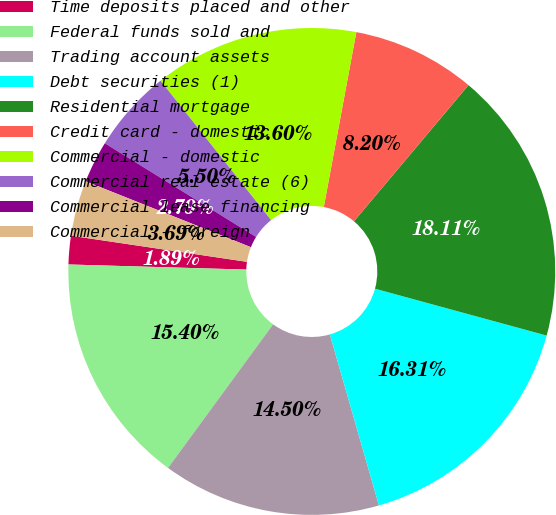Convert chart. <chart><loc_0><loc_0><loc_500><loc_500><pie_chart><fcel>Time deposits placed and other<fcel>Federal funds sold and<fcel>Trading account assets<fcel>Debt securities (1)<fcel>Residential mortgage<fcel>Credit card - domestic<fcel>Commercial - domestic<fcel>Commercial real estate (6)<fcel>Commercial lease financing<fcel>Commercial - foreign<nl><fcel>1.89%<fcel>15.4%<fcel>14.5%<fcel>16.31%<fcel>18.11%<fcel>8.2%<fcel>13.6%<fcel>5.5%<fcel>2.79%<fcel>3.69%<nl></chart> 